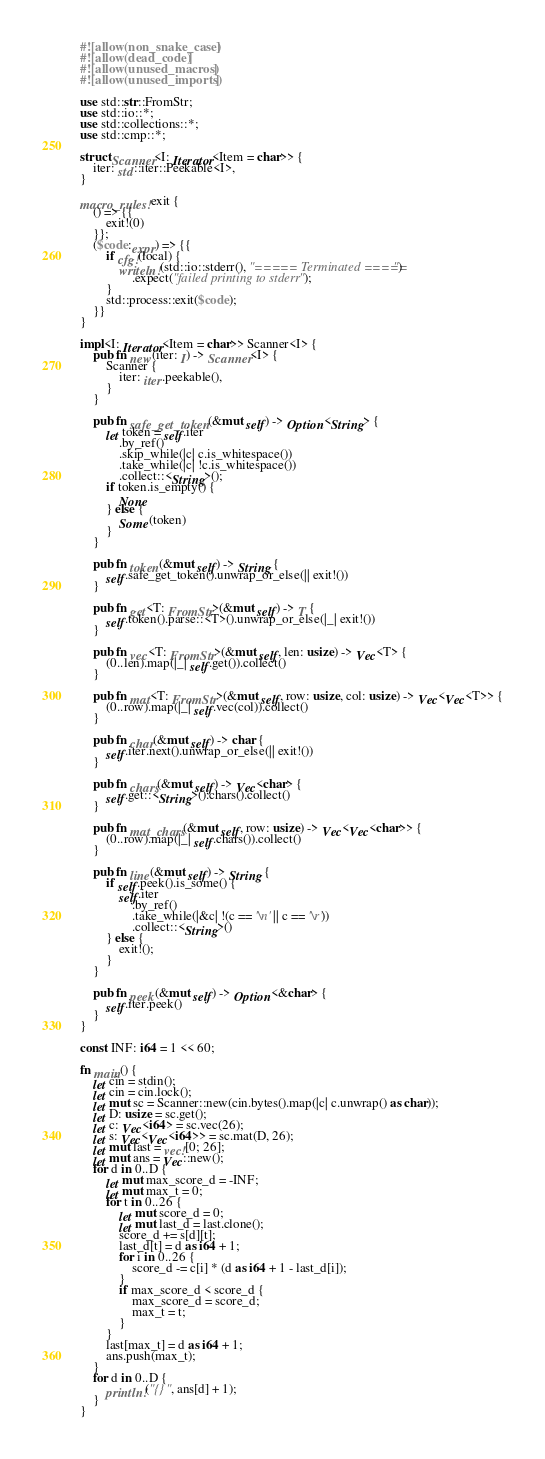Convert code to text. <code><loc_0><loc_0><loc_500><loc_500><_Rust_>#![allow(non_snake_case)]
#![allow(dead_code)]
#![allow(unused_macros)]
#![allow(unused_imports)]

use std::str::FromStr;
use std::io::*;
use std::collections::*;
use std::cmp::*;

struct Scanner<I: Iterator<Item = char>> {
    iter: std::iter::Peekable<I>,
}

macro_rules! exit {
    () => {{
        exit!(0)
    }};
    ($code:expr) => {{
        if cfg!(local) {
            writeln!(std::io::stderr(), "===== Terminated =====")
                .expect("failed printing to stderr");
        }
        std::process::exit($code);
    }}
}

impl<I: Iterator<Item = char>> Scanner<I> {
    pub fn new(iter: I) -> Scanner<I> {
        Scanner {
            iter: iter.peekable(),
        }
    }

    pub fn safe_get_token(&mut self) -> Option<String> {
        let token = self.iter
            .by_ref()
            .skip_while(|c| c.is_whitespace())
            .take_while(|c| !c.is_whitespace())
            .collect::<String>();
        if token.is_empty() {
            None
        } else {
            Some(token)
        }
    }

    pub fn token(&mut self) -> String {
        self.safe_get_token().unwrap_or_else(|| exit!())
    }

    pub fn get<T: FromStr>(&mut self) -> T {
        self.token().parse::<T>().unwrap_or_else(|_| exit!())
    }

    pub fn vec<T: FromStr>(&mut self, len: usize) -> Vec<T> {
        (0..len).map(|_| self.get()).collect()
    }

    pub fn mat<T: FromStr>(&mut self, row: usize, col: usize) -> Vec<Vec<T>> {
        (0..row).map(|_| self.vec(col)).collect()
    }

    pub fn char(&mut self) -> char {
        self.iter.next().unwrap_or_else(|| exit!())
    }

    pub fn chars(&mut self) -> Vec<char> {
        self.get::<String>().chars().collect()
    }

    pub fn mat_chars(&mut self, row: usize) -> Vec<Vec<char>> {
        (0..row).map(|_| self.chars()).collect()
    }

    pub fn line(&mut self) -> String {
        if self.peek().is_some() {
            self.iter
                .by_ref()
                .take_while(|&c| !(c == '\n' || c == '\r'))
                .collect::<String>()
        } else {
            exit!();
        }
    }

    pub fn peek(&mut self) -> Option<&char> {
        self.iter.peek()
    }
}

const INF: i64 = 1 << 60;

fn main() {
    let cin = stdin();
    let cin = cin.lock();
    let mut sc = Scanner::new(cin.bytes().map(|c| c.unwrap() as char));
    let D: usize = sc.get();
    let c: Vec<i64> = sc.vec(26);
    let s: Vec<Vec<i64>> = sc.mat(D, 26);
    let mut last = vec![0; 26];
    let mut ans = Vec::new();
    for d in 0..D {
        let mut max_score_d = -INF;
        let mut max_t = 0;
        for t in 0..26 {
            let mut score_d = 0;
            let mut last_d = last.clone();
            score_d += s[d][t];
            last_d[t] = d as i64 + 1;
            for i in 0..26 {
                score_d -= c[i] * (d as i64 + 1 - last_d[i]);
            }
            if max_score_d < score_d {
                max_score_d = score_d;
                max_t = t;
            }
        }
        last[max_t] = d as i64 + 1;
        ans.push(max_t);
    }
    for d in 0..D {
        println!("{}", ans[d] + 1);
    }
}
</code> 